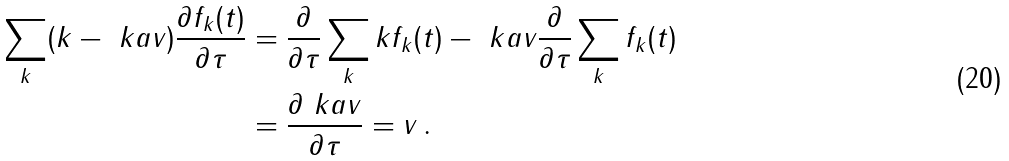<formula> <loc_0><loc_0><loc_500><loc_500>\sum _ { k } ( k - \ k a v ) \frac { \partial f _ { k } ( t ) } { \partial \tau } & = \frac { \partial } { \partial \tau } \sum _ { k } k f _ { k } ( t ) - \ k a v \frac { \partial } { \partial \tau } \sum _ { k } f _ { k } ( t ) \\ & = \frac { \partial \ k a v } { \partial \tau } = v \, .</formula> 